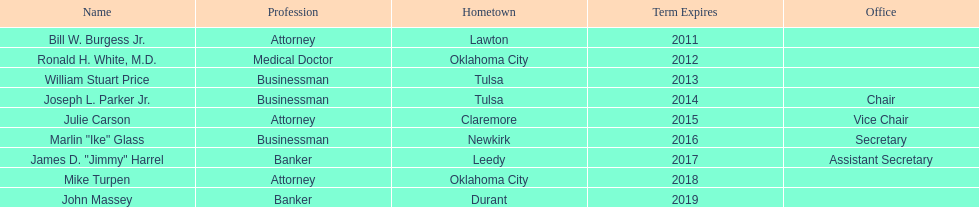From which state's regent does dr. ronald h. white, m.d. have the same hometown as? Mike Turpen. 